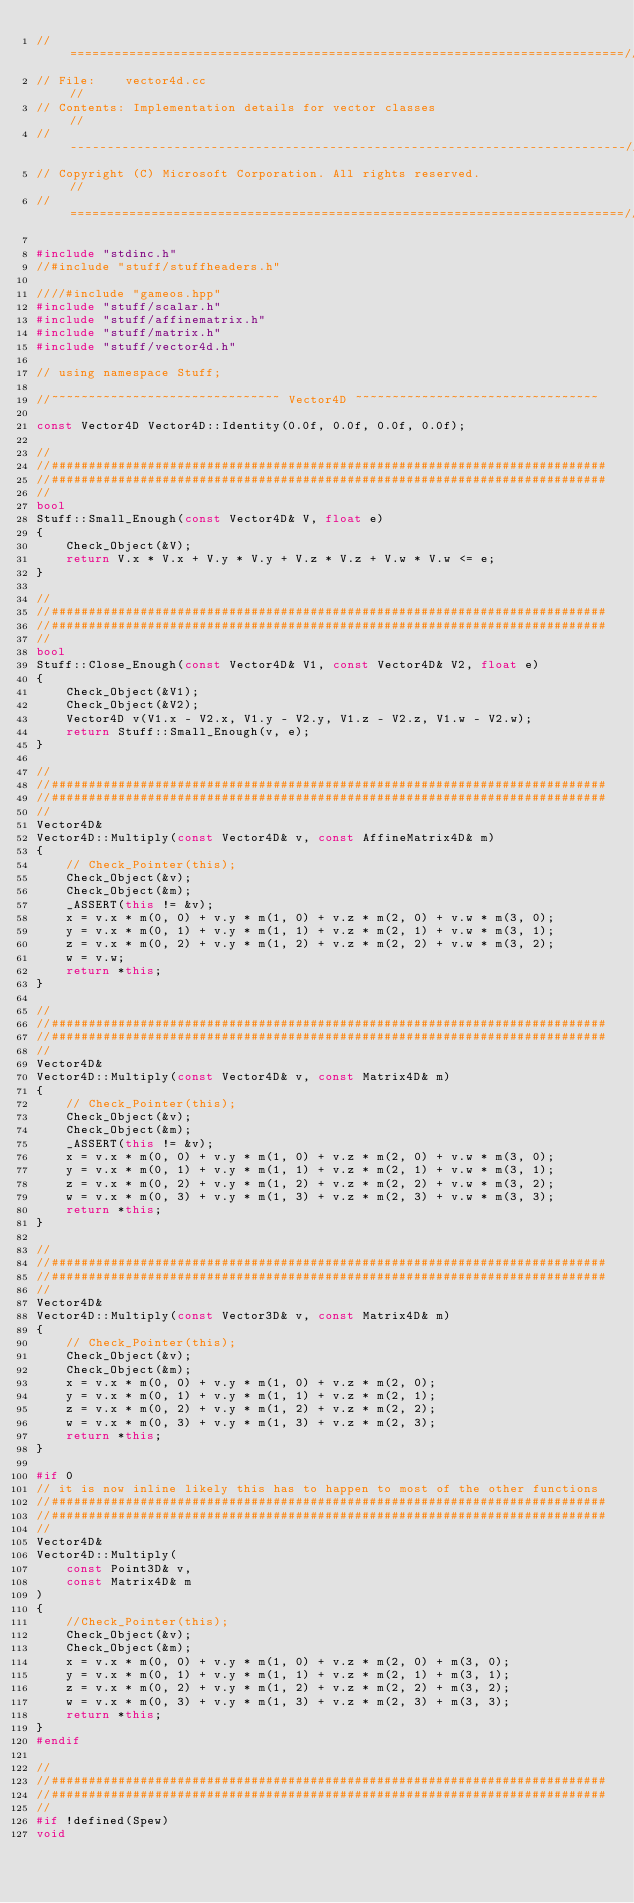Convert code to text. <code><loc_0><loc_0><loc_500><loc_500><_C++_>//===========================================================================//
// File:	vector4d.cc                                                      //
// Contents: Implementation details for vector classes                       //
//---------------------------------------------------------------------------//
// Copyright (C) Microsoft Corporation. All rights reserved.                 //
//===========================================================================//

#include "stdinc.h"
//#include "stuff/stuffheaders.h"

////#include "gameos.hpp"
#include "stuff/scalar.h"
#include "stuff/affinematrix.h"
#include "stuff/matrix.h"
#include "stuff/vector4d.h"

// using namespace Stuff;

//~~~~~~~~~~~~~~~~~~~~~~~~~~~~~~~ Vector4D ~~~~~~~~~~~~~~~~~~~~~~~~~~~~~~~~~

const Vector4D Vector4D::Identity(0.0f, 0.0f, 0.0f, 0.0f);

//
//###########################################################################
//###########################################################################
//
bool
Stuff::Small_Enough(const Vector4D& V, float e)
{
	Check_Object(&V);
	return V.x * V.x + V.y * V.y + V.z * V.z + V.w * V.w <= e;
}

//
//###########################################################################
//###########################################################################
//
bool
Stuff::Close_Enough(const Vector4D& V1, const Vector4D& V2, float e)
{
	Check_Object(&V1);
	Check_Object(&V2);
	Vector4D v(V1.x - V2.x, V1.y - V2.y, V1.z - V2.z, V1.w - V2.w);
	return Stuff::Small_Enough(v, e);
}

//
//###########################################################################
//###########################################################################
//
Vector4D&
Vector4D::Multiply(const Vector4D& v, const AffineMatrix4D& m)
{
	// Check_Pointer(this);
	Check_Object(&v);
	Check_Object(&m);
	_ASSERT(this != &v);
	x = v.x * m(0, 0) + v.y * m(1, 0) + v.z * m(2, 0) + v.w * m(3, 0);
	y = v.x * m(0, 1) + v.y * m(1, 1) + v.z * m(2, 1) + v.w * m(3, 1);
	z = v.x * m(0, 2) + v.y * m(1, 2) + v.z * m(2, 2) + v.w * m(3, 2);
	w = v.w;
	return *this;
}

//
//###########################################################################
//###########################################################################
//
Vector4D&
Vector4D::Multiply(const Vector4D& v, const Matrix4D& m)
{
	// Check_Pointer(this);
	Check_Object(&v);
	Check_Object(&m);
	_ASSERT(this != &v);
	x = v.x * m(0, 0) + v.y * m(1, 0) + v.z * m(2, 0) + v.w * m(3, 0);
	y = v.x * m(0, 1) + v.y * m(1, 1) + v.z * m(2, 1) + v.w * m(3, 1);
	z = v.x * m(0, 2) + v.y * m(1, 2) + v.z * m(2, 2) + v.w * m(3, 2);
	w = v.x * m(0, 3) + v.y * m(1, 3) + v.z * m(2, 3) + v.w * m(3, 3);
	return *this;
}

//
//###########################################################################
//###########################################################################
//
Vector4D&
Vector4D::Multiply(const Vector3D& v, const Matrix4D& m)
{
	// Check_Pointer(this);
	Check_Object(&v);
	Check_Object(&m);
	x = v.x * m(0, 0) + v.y * m(1, 0) + v.z * m(2, 0);
	y = v.x * m(0, 1) + v.y * m(1, 1) + v.z * m(2, 1);
	z = v.x * m(0, 2) + v.y * m(1, 2) + v.z * m(2, 2);
	w = v.x * m(0, 3) + v.y * m(1, 3) + v.z * m(2, 3);
	return *this;
}

#if 0
// it is now inline likely this has to happen to most of the other functions
//###########################################################################
//###########################################################################
//
Vector4D&
Vector4D::Multiply(
	const Point3D& v,
	const Matrix4D& m
)
{
	//Check_Pointer(this);
	Check_Object(&v);
	Check_Object(&m);
	x = v.x * m(0, 0) + v.y * m(1, 0) + v.z * m(2, 0) + m(3, 0);
	y = v.x * m(0, 1) + v.y * m(1, 1) + v.z * m(2, 1) + m(3, 1);
	z = v.x * m(0, 2) + v.y * m(1, 2) + v.z * m(2, 2) + m(3, 2);
	w = v.x * m(0, 3) + v.y * m(1, 3) + v.z * m(2, 3) + m(3, 3);
	return *this;
}
#endif

//
//###########################################################################
//###########################################################################
//
#if !defined(Spew)
void</code> 